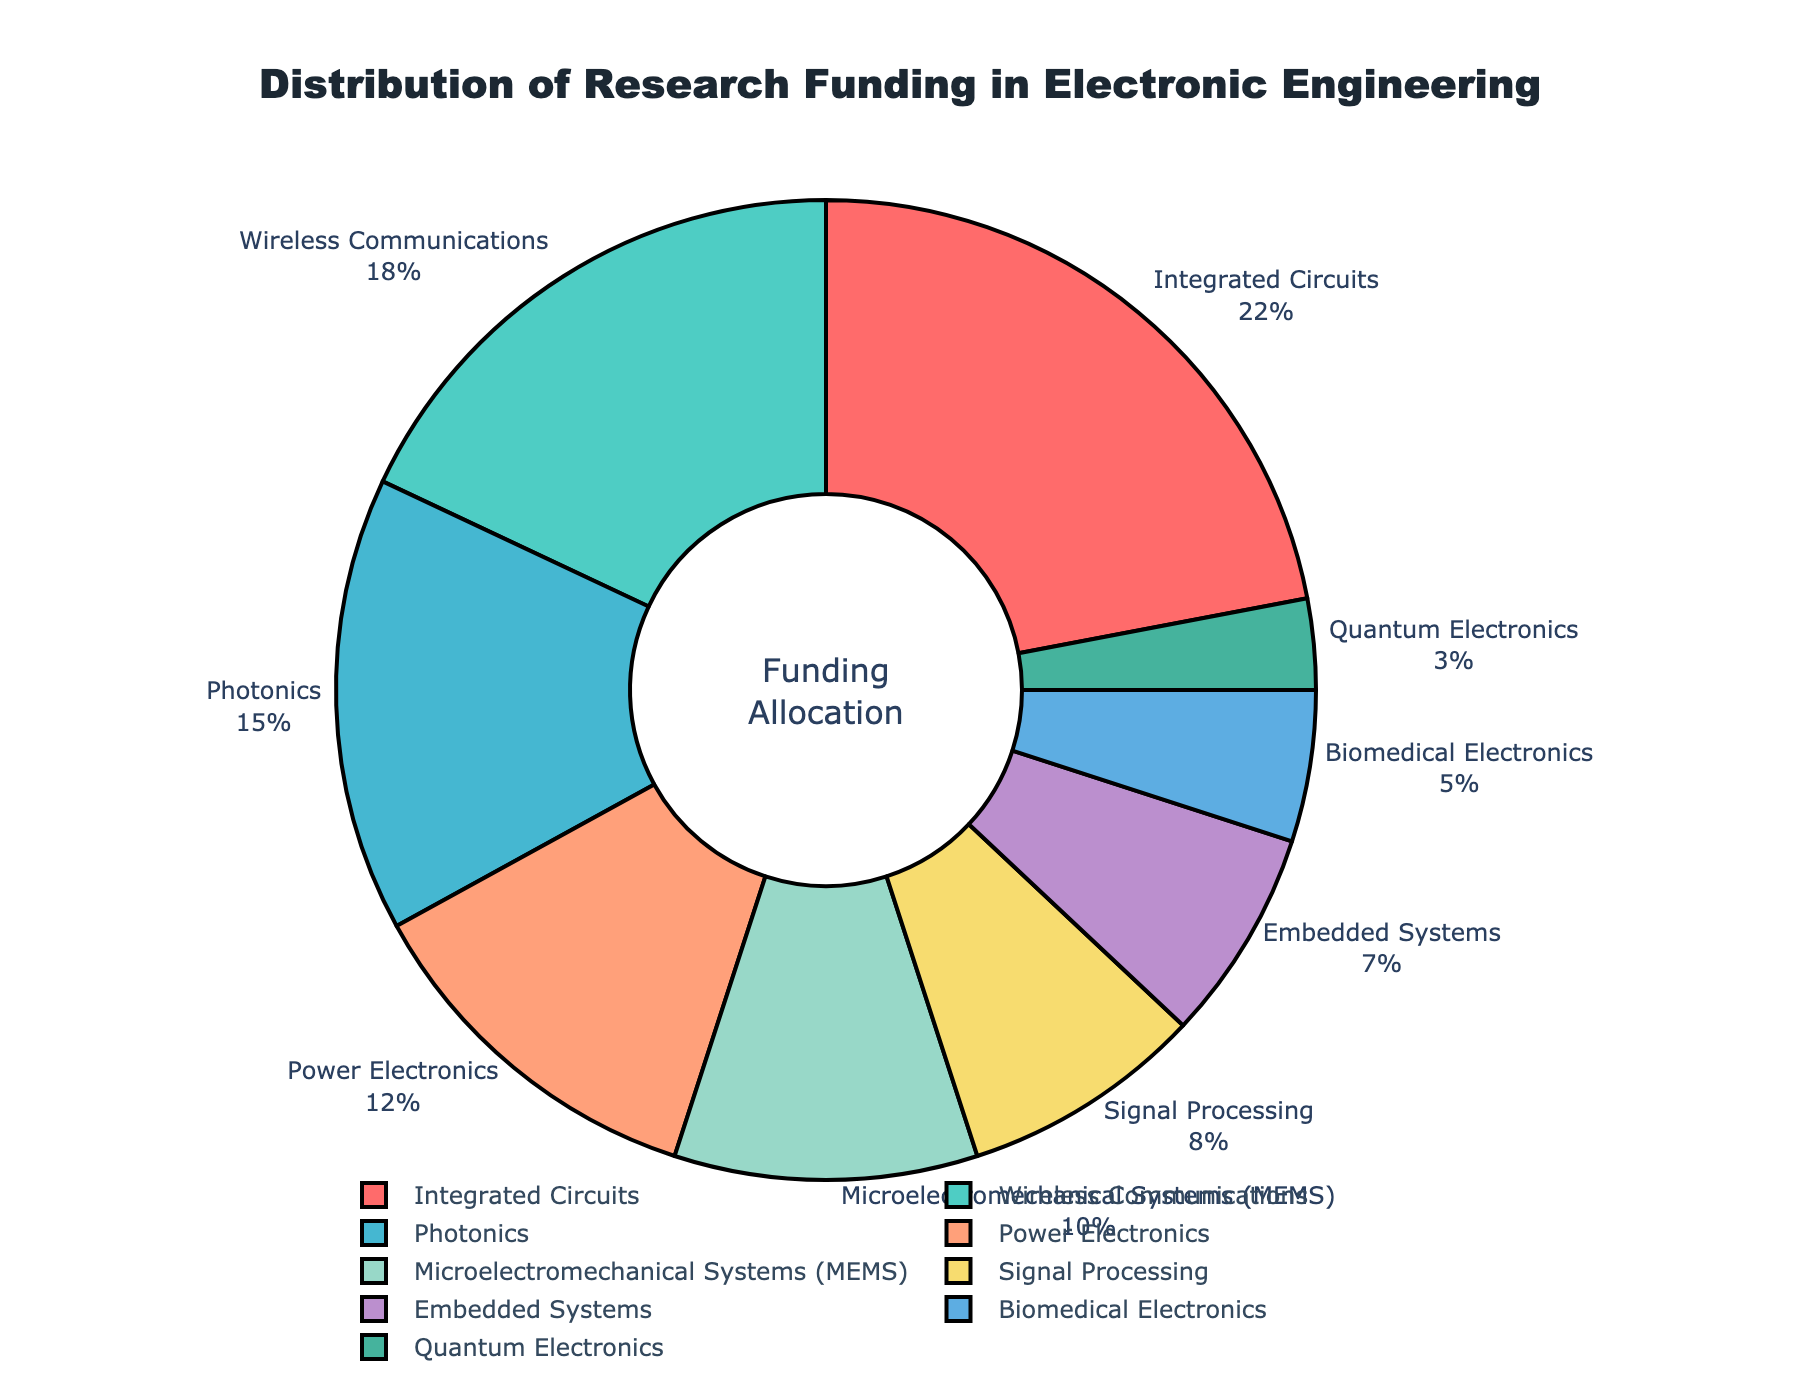Which research area has the highest share of funding allocation? The research area with the highest percentage of the pie chart represents the largest funding allocation. By examining the chart, the segment labeled "Integrated Circuits" is the largest.
Answer: Integrated Circuits What is the combined funding percentage for Power Electronics and Signal Processing? To find the combined funding for Power Electronics and Signal Processing, add their individual percentages: 12% + 8% = 20%.
Answer: 20% How does the funding allocated to Biomedical Electronics compare with Quantum Electronics? Comparing the two segments, Biomedical Electronics has a funding percentage of 5%, while Quantum Electronics has 3%. Biomedical Electronics has 2% more funding than Quantum Electronics.
Answer: Biomedical Electronics has 2% more funding Which research area has a larger funding proportion: Photonics or MEMS? From the pie chart, Photonics has a funding percentage of 15%, and MEMS has 10%. Photonics has a larger funding proportion than MEMS.
Answer: Photonics What is the total funding percentage for research areas with more than 10% funding? Identify the research areas that exceed 10% funding: Integrated Circuits (22%), Wireless Communications (18%), Photonics (15%), and Power Electronics (12%). Add these percentages: 22% + 18% + 15% + 12% = 67%.
Answer: 67% Among the lower-funded areas, what is the share of Embedded Systems? Lower-funded areas generally refer to those with funding percentages below 10%. Embedded Systems is one of these areas with a funding percentage of 7%.
Answer: 7% How much more funding does Integrated Circuits receive compared to Signal Processing? Subtract the funding percentage of Signal Processing from Integrated Circuits: 22% - 8% = 14%.
Answer: 14% Is the funding allocation for Wireless Communications closer to 10% or 20%? Wireless Communications has a funding percentage of 18%, which is closer to 20% than 10%.
Answer: 20% Which color represents the research area with the smallest funding share, and what is its percentage? The research area with the smallest funding share is Quantum Electronics with 3%, represented by the color corresponding to its segment. By examining the chart, Quantum Electronics is shown in a shade of green.
Answer: Green, 3% If funding for Integrated Circuits was reduced by 5% and given to Quantum Electronics, what would the new funding percentages be? Integrated Circuits currently have 22%, and Quantum Electronics have 3%. Reducing Integrated Circuits by 5% gives them 22% - 5% = 17%, and adding this 5% to Quantum Electronics gives them 3% + 5% = 8%.
Answer: Integrated Circuits: 17%, Quantum Electronics: 8% 